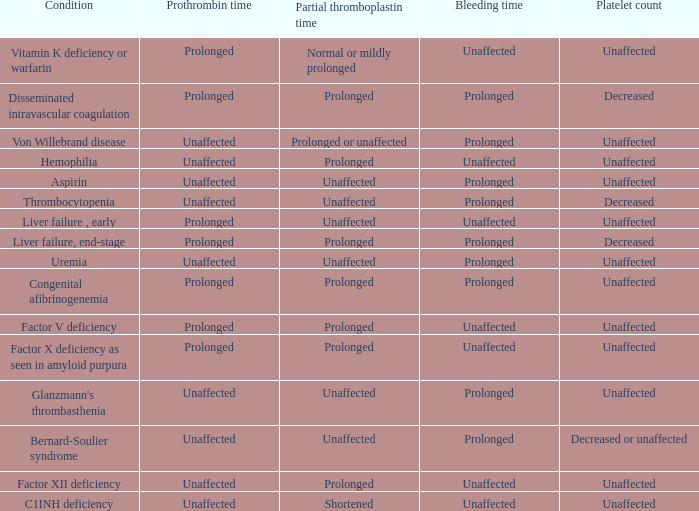What medical condition presents with a normal bleeding time, an extended partial thromboplastin time, and a stable prothrombin time? Hemophilia, Factor XII deficiency. 